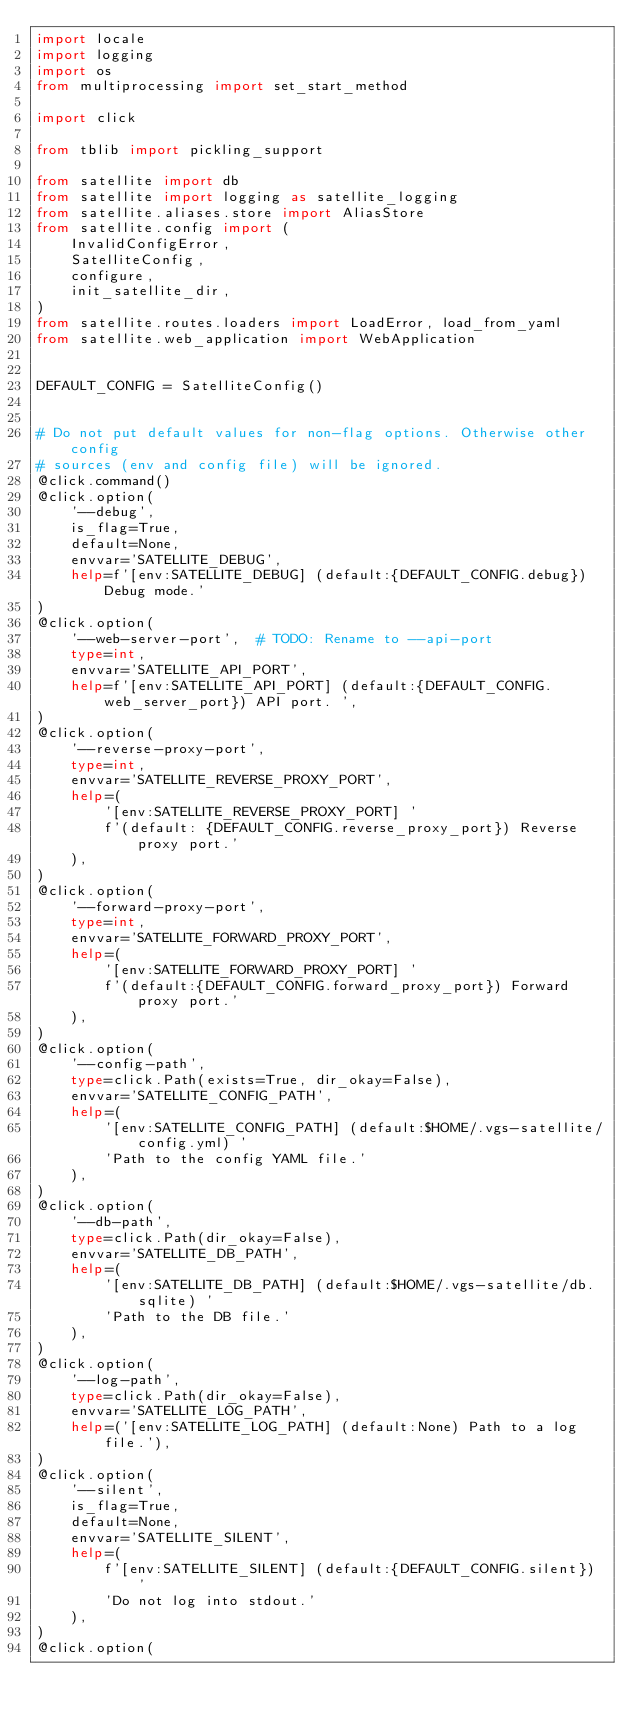<code> <loc_0><loc_0><loc_500><loc_500><_Python_>import locale
import logging
import os
from multiprocessing import set_start_method

import click

from tblib import pickling_support

from satellite import db
from satellite import logging as satellite_logging
from satellite.aliases.store import AliasStore
from satellite.config import (
    InvalidConfigError,
    SatelliteConfig,
    configure,
    init_satellite_dir,
)
from satellite.routes.loaders import LoadError, load_from_yaml
from satellite.web_application import WebApplication


DEFAULT_CONFIG = SatelliteConfig()


# Do not put default values for non-flag options. Otherwise other config
# sources (env and config file) will be ignored.
@click.command()
@click.option(
    '--debug',
    is_flag=True,
    default=None,
    envvar='SATELLITE_DEBUG',
    help=f'[env:SATELLITE_DEBUG] (default:{DEFAULT_CONFIG.debug}) Debug mode.'
)
@click.option(
    '--web-server-port',  # TODO: Rename to --api-port
    type=int,
    envvar='SATELLITE_API_PORT',
    help=f'[env:SATELLITE_API_PORT] (default:{DEFAULT_CONFIG.web_server_port}) API port. ',
)
@click.option(
    '--reverse-proxy-port',
    type=int,
    envvar='SATELLITE_REVERSE_PROXY_PORT',
    help=(
        '[env:SATELLITE_REVERSE_PROXY_PORT] '
        f'(default: {DEFAULT_CONFIG.reverse_proxy_port}) Reverse proxy port.'
    ),
)
@click.option(
    '--forward-proxy-port',
    type=int,
    envvar='SATELLITE_FORWARD_PROXY_PORT',
    help=(
        '[env:SATELLITE_FORWARD_PROXY_PORT] '
        f'(default:{DEFAULT_CONFIG.forward_proxy_port}) Forward proxy port.'
    ),
)
@click.option(
    '--config-path',
    type=click.Path(exists=True, dir_okay=False),
    envvar='SATELLITE_CONFIG_PATH',
    help=(
        '[env:SATELLITE_CONFIG_PATH] (default:$HOME/.vgs-satellite/config.yml) '
        'Path to the config YAML file.'
    ),
)
@click.option(
    '--db-path',
    type=click.Path(dir_okay=False),
    envvar='SATELLITE_DB_PATH',
    help=(
        '[env:SATELLITE_DB_PATH] (default:$HOME/.vgs-satellite/db.sqlite) '
        'Path to the DB file.'
    ),
)
@click.option(
    '--log-path',
    type=click.Path(dir_okay=False),
    envvar='SATELLITE_LOG_PATH',
    help=('[env:SATELLITE_LOG_PATH] (default:None) Path to a log file.'),
)
@click.option(
    '--silent',
    is_flag=True,
    default=None,
    envvar='SATELLITE_SILENT',
    help=(
        f'[env:SATELLITE_SILENT] (default:{DEFAULT_CONFIG.silent}) '
        'Do not log into stdout.'
    ),
)
@click.option(</code> 